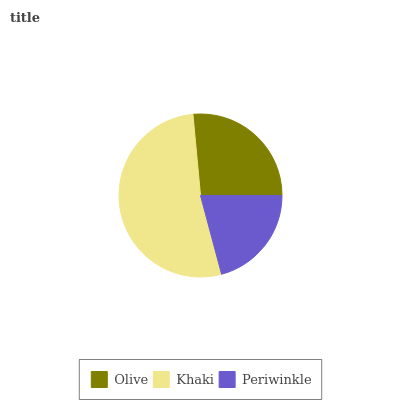Is Periwinkle the minimum?
Answer yes or no. Yes. Is Khaki the maximum?
Answer yes or no. Yes. Is Khaki the minimum?
Answer yes or no. No. Is Periwinkle the maximum?
Answer yes or no. No. Is Khaki greater than Periwinkle?
Answer yes or no. Yes. Is Periwinkle less than Khaki?
Answer yes or no. Yes. Is Periwinkle greater than Khaki?
Answer yes or no. No. Is Khaki less than Periwinkle?
Answer yes or no. No. Is Olive the high median?
Answer yes or no. Yes. Is Olive the low median?
Answer yes or no. Yes. Is Periwinkle the high median?
Answer yes or no. No. Is Periwinkle the low median?
Answer yes or no. No. 